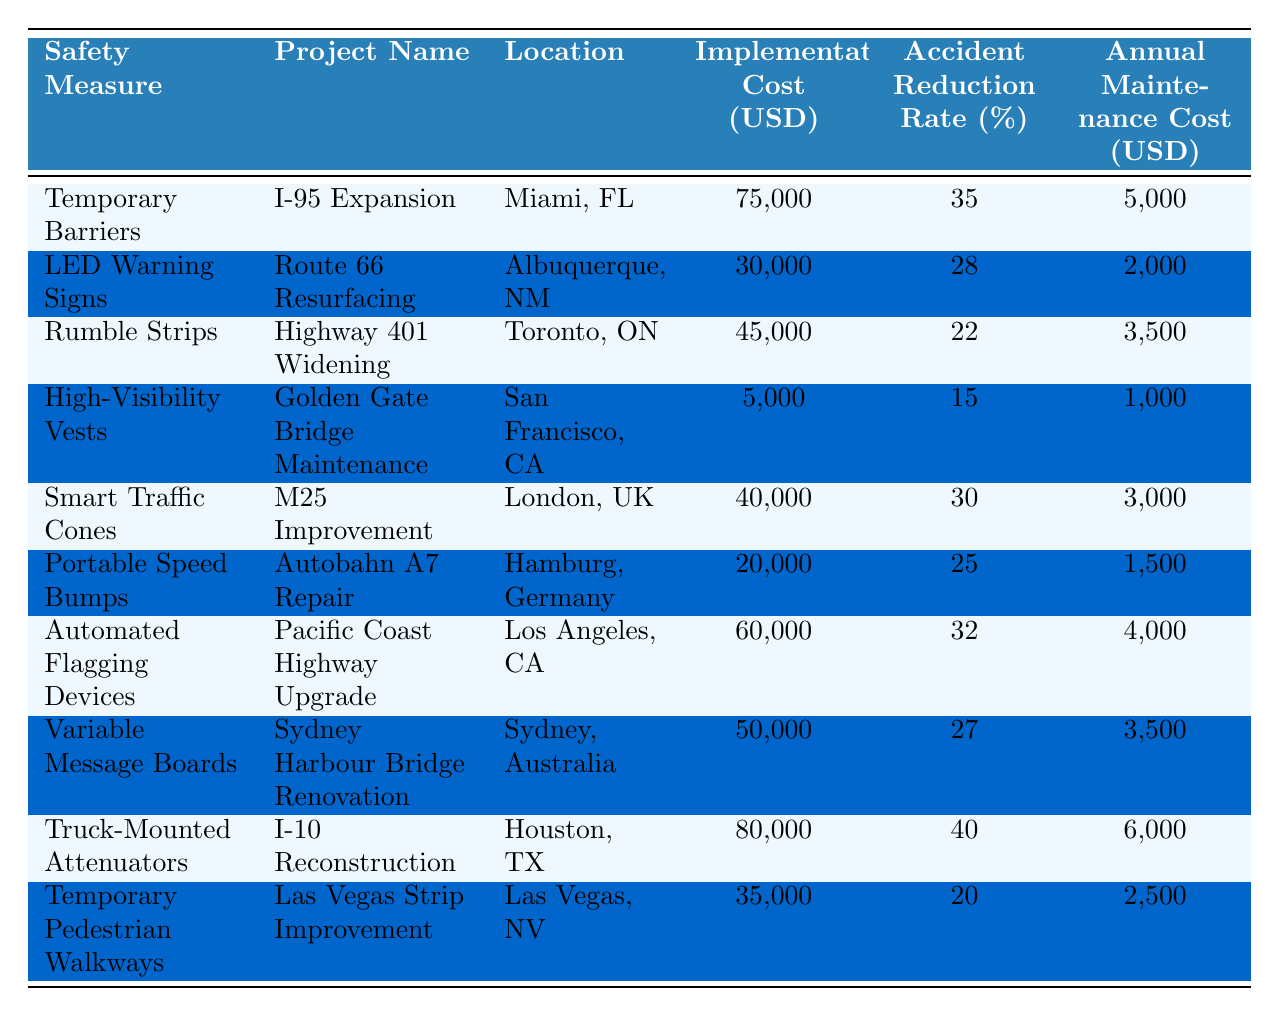What is the implementation cost of Automated Flagging Devices? According to the table, the implementation cost of Automated Flagging Devices is listed as 60,000 USD.
Answer: 60,000 USD Which project had the highest accident reduction rate? By scanning the data for the Accident Reduction Rate, Truck-Mounted Attenuators has the highest rate at 40%.
Answer: 40% What is the total implementation cost of all road safety measures? To find the total, sum the implementation costs: 75,000 + 30,000 + 45,000 + 5,000 + 40,000 + 20,000 + 60,000 + 50,000 + 80,000 + 35,000 = 440,000 USD.
Answer: 440,000 USD Is the annual maintenance cost for Rumble Strips less than 4,000 USD? The table shows that the annual maintenance cost for Rumble Strips is 3,500 USD, which is indeed less than 4,000 USD.
Answer: Yes What is the average accident reduction rate of all measures? The average can be calculated by summing the accident reduction rates (35 + 28 + 22 + 15 + 30 + 25 + 32 + 27 + 40 + 20) which totals 304, and then dividing by the number of measures (10) to get an average of 30.4%.
Answer: 30.4% Which road safety measure has the lowest implementation cost? It can be seen that High-Visibility Vests has the lowest implementation cost at 5,000 USD compared to others.
Answer: 5,000 USD How many projects have an accident reduction rate greater than 25%? The measures with a reduction rate greater than 25% are Temporary Barriers (35%), Smart Traffic Cones (30%), Automated Flagging Devices (32%), Truck-Mounted Attenuators (40%). That gives us a total of 4 projects.
Answer: 4 projects If you combine the costs of Temporary Pedestrian Walkways and LED Warning Signs, do they exceed 70,000 USD? The total combined costs are 35,000 (Temporary Pedestrian Walkways) + 30,000 (LED Warning Signs) = 65,000 USD. Since 65,000 is less than 70,000, the answer is no.
Answer: No What percentage of the projects have an implementation cost of over 50,000 USD? The projects with costs over 50,000 USD are Truck-Mounted Attenuators (80,000), Automated Flagging Devices (60,000), and Variable Message Boards (50,000) totaling 3 projects. Thus, the percentage is (3/10) * 100 = 30%.
Answer: 30% Which measure is associated with the location of Golden Gate Bridge? The table indicates that High-Visibility Vests are associated with the Golden Gate Bridge Maintenance project in San Francisco, CA.
Answer: High-Visibility Vests 